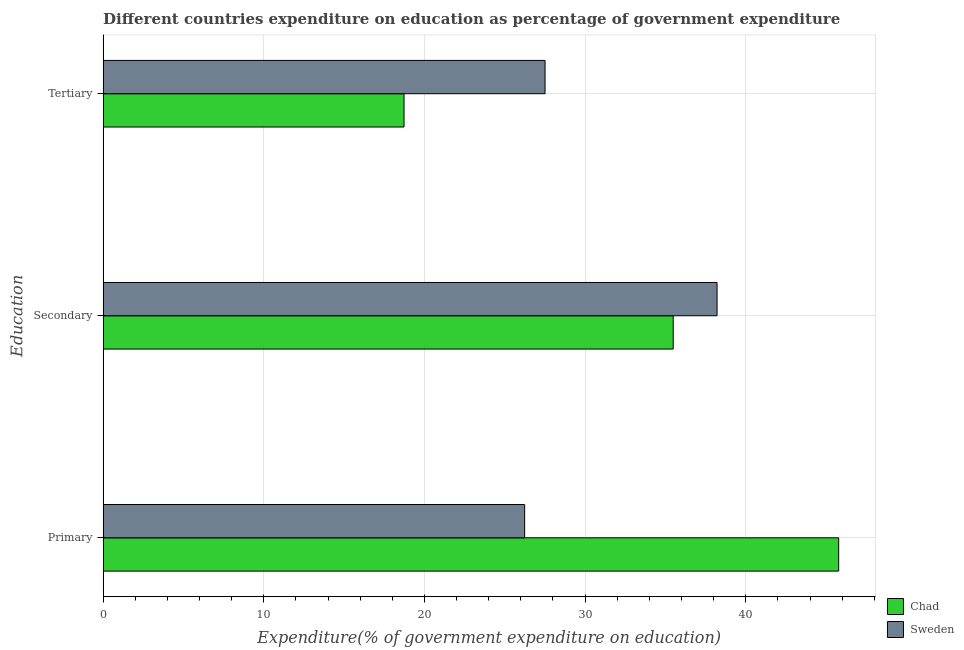How many groups of bars are there?
Ensure brevity in your answer.  3. Are the number of bars per tick equal to the number of legend labels?
Provide a short and direct response. Yes. Are the number of bars on each tick of the Y-axis equal?
Provide a short and direct response. Yes. How many bars are there on the 3rd tick from the top?
Your answer should be very brief. 2. How many bars are there on the 2nd tick from the bottom?
Keep it short and to the point. 2. What is the label of the 2nd group of bars from the top?
Your answer should be very brief. Secondary. What is the expenditure on tertiary education in Chad?
Provide a succinct answer. 18.73. Across all countries, what is the maximum expenditure on secondary education?
Provide a short and direct response. 38.21. Across all countries, what is the minimum expenditure on primary education?
Ensure brevity in your answer.  26.24. In which country was the expenditure on tertiary education maximum?
Offer a very short reply. Sweden. In which country was the expenditure on primary education minimum?
Offer a terse response. Sweden. What is the total expenditure on primary education in the graph?
Offer a terse response. 72.02. What is the difference between the expenditure on tertiary education in Chad and that in Sweden?
Provide a short and direct response. -8.78. What is the difference between the expenditure on secondary education in Chad and the expenditure on primary education in Sweden?
Offer a terse response. 9.25. What is the average expenditure on tertiary education per country?
Provide a short and direct response. 23.12. What is the difference between the expenditure on primary education and expenditure on tertiary education in Sweden?
Provide a short and direct response. -1.27. What is the ratio of the expenditure on secondary education in Sweden to that in Chad?
Provide a succinct answer. 1.08. Is the expenditure on secondary education in Sweden less than that in Chad?
Keep it short and to the point. No. Is the difference between the expenditure on primary education in Chad and Sweden greater than the difference between the expenditure on secondary education in Chad and Sweden?
Provide a short and direct response. Yes. What is the difference between the highest and the second highest expenditure on tertiary education?
Your answer should be very brief. 8.78. What is the difference between the highest and the lowest expenditure on secondary education?
Ensure brevity in your answer.  2.73. What does the 2nd bar from the top in Tertiary represents?
Make the answer very short. Chad. What does the 1st bar from the bottom in Secondary represents?
Offer a very short reply. Chad. How many countries are there in the graph?
Make the answer very short. 2. What is the difference between two consecutive major ticks on the X-axis?
Make the answer very short. 10. Are the values on the major ticks of X-axis written in scientific E-notation?
Your response must be concise. No. Does the graph contain any zero values?
Keep it short and to the point. No. How are the legend labels stacked?
Offer a very short reply. Vertical. What is the title of the graph?
Your answer should be compact. Different countries expenditure on education as percentage of government expenditure. What is the label or title of the X-axis?
Give a very brief answer. Expenditure(% of government expenditure on education). What is the label or title of the Y-axis?
Ensure brevity in your answer.  Education. What is the Expenditure(% of government expenditure on education) in Chad in Primary?
Make the answer very short. 45.78. What is the Expenditure(% of government expenditure on education) of Sweden in Primary?
Your response must be concise. 26.24. What is the Expenditure(% of government expenditure on education) in Chad in Secondary?
Give a very brief answer. 35.48. What is the Expenditure(% of government expenditure on education) in Sweden in Secondary?
Provide a short and direct response. 38.21. What is the Expenditure(% of government expenditure on education) in Chad in Tertiary?
Your answer should be very brief. 18.73. What is the Expenditure(% of government expenditure on education) of Sweden in Tertiary?
Make the answer very short. 27.51. Across all Education, what is the maximum Expenditure(% of government expenditure on education) of Chad?
Provide a succinct answer. 45.78. Across all Education, what is the maximum Expenditure(% of government expenditure on education) of Sweden?
Make the answer very short. 38.21. Across all Education, what is the minimum Expenditure(% of government expenditure on education) of Chad?
Keep it short and to the point. 18.73. Across all Education, what is the minimum Expenditure(% of government expenditure on education) in Sweden?
Provide a short and direct response. 26.24. What is the total Expenditure(% of government expenditure on education) in Chad in the graph?
Provide a succinct answer. 100. What is the total Expenditure(% of government expenditure on education) of Sweden in the graph?
Keep it short and to the point. 91.96. What is the difference between the Expenditure(% of government expenditure on education) in Chad in Primary and that in Secondary?
Offer a terse response. 10.3. What is the difference between the Expenditure(% of government expenditure on education) of Sweden in Primary and that in Secondary?
Offer a terse response. -11.98. What is the difference between the Expenditure(% of government expenditure on education) of Chad in Primary and that in Tertiary?
Your answer should be compact. 27.05. What is the difference between the Expenditure(% of government expenditure on education) of Sweden in Primary and that in Tertiary?
Your response must be concise. -1.27. What is the difference between the Expenditure(% of government expenditure on education) in Chad in Secondary and that in Tertiary?
Give a very brief answer. 16.75. What is the difference between the Expenditure(% of government expenditure on education) in Sweden in Secondary and that in Tertiary?
Give a very brief answer. 10.71. What is the difference between the Expenditure(% of government expenditure on education) in Chad in Primary and the Expenditure(% of government expenditure on education) in Sweden in Secondary?
Keep it short and to the point. 7.57. What is the difference between the Expenditure(% of government expenditure on education) of Chad in Primary and the Expenditure(% of government expenditure on education) of Sweden in Tertiary?
Your response must be concise. 18.28. What is the difference between the Expenditure(% of government expenditure on education) of Chad in Secondary and the Expenditure(% of government expenditure on education) of Sweden in Tertiary?
Give a very brief answer. 7.98. What is the average Expenditure(% of government expenditure on education) in Chad per Education?
Make the answer very short. 33.33. What is the average Expenditure(% of government expenditure on education) of Sweden per Education?
Your answer should be very brief. 30.65. What is the difference between the Expenditure(% of government expenditure on education) in Chad and Expenditure(% of government expenditure on education) in Sweden in Primary?
Give a very brief answer. 19.55. What is the difference between the Expenditure(% of government expenditure on education) in Chad and Expenditure(% of government expenditure on education) in Sweden in Secondary?
Keep it short and to the point. -2.73. What is the difference between the Expenditure(% of government expenditure on education) of Chad and Expenditure(% of government expenditure on education) of Sweden in Tertiary?
Your response must be concise. -8.78. What is the ratio of the Expenditure(% of government expenditure on education) of Chad in Primary to that in Secondary?
Offer a terse response. 1.29. What is the ratio of the Expenditure(% of government expenditure on education) of Sweden in Primary to that in Secondary?
Your answer should be compact. 0.69. What is the ratio of the Expenditure(% of government expenditure on education) in Chad in Primary to that in Tertiary?
Offer a very short reply. 2.44. What is the ratio of the Expenditure(% of government expenditure on education) in Sweden in Primary to that in Tertiary?
Offer a terse response. 0.95. What is the ratio of the Expenditure(% of government expenditure on education) of Chad in Secondary to that in Tertiary?
Offer a very short reply. 1.89. What is the ratio of the Expenditure(% of government expenditure on education) in Sweden in Secondary to that in Tertiary?
Ensure brevity in your answer.  1.39. What is the difference between the highest and the second highest Expenditure(% of government expenditure on education) of Chad?
Give a very brief answer. 10.3. What is the difference between the highest and the second highest Expenditure(% of government expenditure on education) in Sweden?
Offer a terse response. 10.71. What is the difference between the highest and the lowest Expenditure(% of government expenditure on education) of Chad?
Your response must be concise. 27.05. What is the difference between the highest and the lowest Expenditure(% of government expenditure on education) in Sweden?
Your answer should be compact. 11.98. 